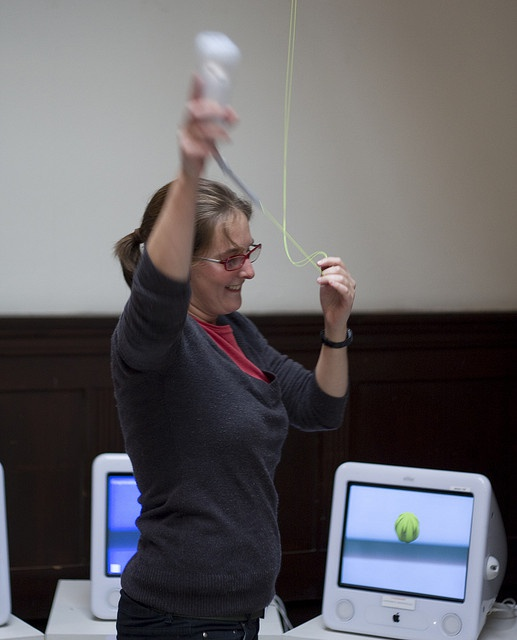Describe the objects in this image and their specific colors. I can see people in darkgray, black, gray, and maroon tones, tv in darkgray, lavender, and gray tones, tv in darkgray, lightblue, black, and blue tones, and remote in darkgray and lightgray tones in this image. 